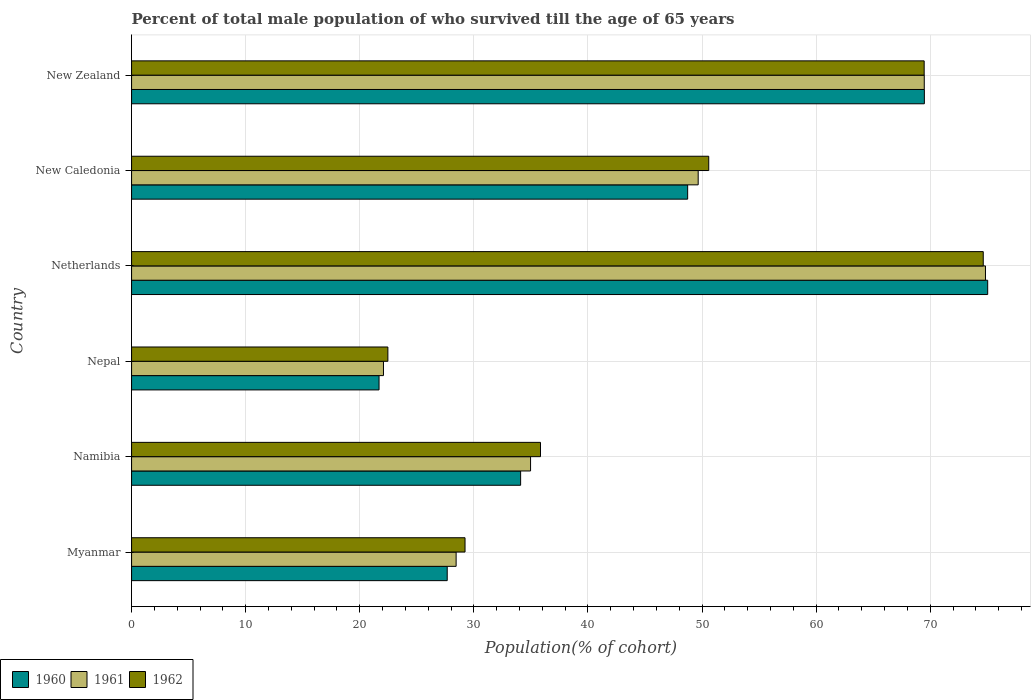Are the number of bars on each tick of the Y-axis equal?
Make the answer very short. Yes. How many bars are there on the 1st tick from the top?
Your answer should be compact. 3. What is the label of the 5th group of bars from the top?
Ensure brevity in your answer.  Namibia. In how many cases, is the number of bars for a given country not equal to the number of legend labels?
Provide a succinct answer. 0. What is the percentage of total male population who survived till the age of 65 years in 1960 in Netherlands?
Your response must be concise. 75.04. Across all countries, what is the maximum percentage of total male population who survived till the age of 65 years in 1962?
Keep it short and to the point. 74.65. Across all countries, what is the minimum percentage of total male population who survived till the age of 65 years in 1961?
Keep it short and to the point. 22.08. In which country was the percentage of total male population who survived till the age of 65 years in 1962 maximum?
Provide a short and direct response. Netherlands. In which country was the percentage of total male population who survived till the age of 65 years in 1962 minimum?
Your response must be concise. Nepal. What is the total percentage of total male population who survived till the age of 65 years in 1960 in the graph?
Your answer should be compact. 276.73. What is the difference between the percentage of total male population who survived till the age of 65 years in 1961 in Netherlands and that in New Zealand?
Offer a terse response. 5.36. What is the difference between the percentage of total male population who survived till the age of 65 years in 1962 in Netherlands and the percentage of total male population who survived till the age of 65 years in 1960 in New Caledonia?
Keep it short and to the point. 25.91. What is the average percentage of total male population who survived till the age of 65 years in 1962 per country?
Offer a very short reply. 47.04. What is the difference between the percentage of total male population who survived till the age of 65 years in 1961 and percentage of total male population who survived till the age of 65 years in 1962 in Netherlands?
Your answer should be compact. 0.19. In how many countries, is the percentage of total male population who survived till the age of 65 years in 1962 greater than 10 %?
Provide a short and direct response. 6. What is the ratio of the percentage of total male population who survived till the age of 65 years in 1962 in Nepal to that in Netherlands?
Your answer should be compact. 0.3. Is the percentage of total male population who survived till the age of 65 years in 1962 in Myanmar less than that in Nepal?
Your answer should be very brief. No. Is the difference between the percentage of total male population who survived till the age of 65 years in 1961 in Nepal and Netherlands greater than the difference between the percentage of total male population who survived till the age of 65 years in 1962 in Nepal and Netherlands?
Your answer should be compact. No. What is the difference between the highest and the second highest percentage of total male population who survived till the age of 65 years in 1961?
Provide a short and direct response. 5.36. What is the difference between the highest and the lowest percentage of total male population who survived till the age of 65 years in 1960?
Provide a short and direct response. 53.35. In how many countries, is the percentage of total male population who survived till the age of 65 years in 1961 greater than the average percentage of total male population who survived till the age of 65 years in 1961 taken over all countries?
Ensure brevity in your answer.  3. What does the 2nd bar from the top in Myanmar represents?
Offer a very short reply. 1961. Is it the case that in every country, the sum of the percentage of total male population who survived till the age of 65 years in 1961 and percentage of total male population who survived till the age of 65 years in 1960 is greater than the percentage of total male population who survived till the age of 65 years in 1962?
Give a very brief answer. Yes. Are all the bars in the graph horizontal?
Offer a very short reply. Yes. Are the values on the major ticks of X-axis written in scientific E-notation?
Provide a short and direct response. No. Does the graph contain grids?
Offer a very short reply. Yes. What is the title of the graph?
Your answer should be very brief. Percent of total male population of who survived till the age of 65 years. What is the label or title of the X-axis?
Provide a short and direct response. Population(% of cohort). What is the Population(% of cohort) of 1960 in Myanmar?
Provide a succinct answer. 27.67. What is the Population(% of cohort) of 1961 in Myanmar?
Your response must be concise. 28.45. What is the Population(% of cohort) of 1962 in Myanmar?
Ensure brevity in your answer.  29.23. What is the Population(% of cohort) in 1960 in Namibia?
Make the answer very short. 34.1. What is the Population(% of cohort) of 1961 in Namibia?
Ensure brevity in your answer.  34.97. What is the Population(% of cohort) of 1962 in Namibia?
Make the answer very short. 35.84. What is the Population(% of cohort) in 1960 in Nepal?
Provide a short and direct response. 21.69. What is the Population(% of cohort) in 1961 in Nepal?
Ensure brevity in your answer.  22.08. What is the Population(% of cohort) in 1962 in Nepal?
Ensure brevity in your answer.  22.46. What is the Population(% of cohort) in 1960 in Netherlands?
Give a very brief answer. 75.04. What is the Population(% of cohort) of 1961 in Netherlands?
Your response must be concise. 74.84. What is the Population(% of cohort) in 1962 in Netherlands?
Provide a succinct answer. 74.65. What is the Population(% of cohort) in 1960 in New Caledonia?
Ensure brevity in your answer.  48.74. What is the Population(% of cohort) in 1961 in New Caledonia?
Your response must be concise. 49.66. What is the Population(% of cohort) in 1962 in New Caledonia?
Your response must be concise. 50.59. What is the Population(% of cohort) of 1960 in New Zealand?
Your answer should be very brief. 69.49. What is the Population(% of cohort) in 1961 in New Zealand?
Provide a succinct answer. 69.48. What is the Population(% of cohort) in 1962 in New Zealand?
Your response must be concise. 69.47. Across all countries, what is the maximum Population(% of cohort) in 1960?
Offer a terse response. 75.04. Across all countries, what is the maximum Population(% of cohort) in 1961?
Ensure brevity in your answer.  74.84. Across all countries, what is the maximum Population(% of cohort) in 1962?
Your answer should be very brief. 74.65. Across all countries, what is the minimum Population(% of cohort) in 1960?
Ensure brevity in your answer.  21.69. Across all countries, what is the minimum Population(% of cohort) of 1961?
Provide a succinct answer. 22.08. Across all countries, what is the minimum Population(% of cohort) of 1962?
Your response must be concise. 22.46. What is the total Population(% of cohort) in 1960 in the graph?
Your response must be concise. 276.73. What is the total Population(% of cohort) in 1961 in the graph?
Ensure brevity in your answer.  279.48. What is the total Population(% of cohort) in 1962 in the graph?
Make the answer very short. 282.24. What is the difference between the Population(% of cohort) of 1960 in Myanmar and that in Namibia?
Provide a succinct answer. -6.43. What is the difference between the Population(% of cohort) in 1961 in Myanmar and that in Namibia?
Offer a very short reply. -6.52. What is the difference between the Population(% of cohort) of 1962 in Myanmar and that in Namibia?
Provide a succinct answer. -6.62. What is the difference between the Population(% of cohort) of 1960 in Myanmar and that in Nepal?
Offer a very short reply. 5.98. What is the difference between the Population(% of cohort) of 1961 in Myanmar and that in Nepal?
Make the answer very short. 6.37. What is the difference between the Population(% of cohort) of 1962 in Myanmar and that in Nepal?
Provide a short and direct response. 6.76. What is the difference between the Population(% of cohort) in 1960 in Myanmar and that in Netherlands?
Your answer should be very brief. -47.37. What is the difference between the Population(% of cohort) of 1961 in Myanmar and that in Netherlands?
Your response must be concise. -46.4. What is the difference between the Population(% of cohort) of 1962 in Myanmar and that in Netherlands?
Offer a very short reply. -45.42. What is the difference between the Population(% of cohort) in 1960 in Myanmar and that in New Caledonia?
Your answer should be compact. -21.07. What is the difference between the Population(% of cohort) of 1961 in Myanmar and that in New Caledonia?
Give a very brief answer. -21.22. What is the difference between the Population(% of cohort) in 1962 in Myanmar and that in New Caledonia?
Make the answer very short. -21.36. What is the difference between the Population(% of cohort) in 1960 in Myanmar and that in New Zealand?
Offer a very short reply. -41.82. What is the difference between the Population(% of cohort) of 1961 in Myanmar and that in New Zealand?
Give a very brief answer. -41.03. What is the difference between the Population(% of cohort) in 1962 in Myanmar and that in New Zealand?
Provide a succinct answer. -40.24. What is the difference between the Population(% of cohort) of 1960 in Namibia and that in Nepal?
Offer a very short reply. 12.41. What is the difference between the Population(% of cohort) in 1961 in Namibia and that in Nepal?
Keep it short and to the point. 12.89. What is the difference between the Population(% of cohort) of 1962 in Namibia and that in Nepal?
Provide a short and direct response. 13.38. What is the difference between the Population(% of cohort) of 1960 in Namibia and that in Netherlands?
Make the answer very short. -40.94. What is the difference between the Population(% of cohort) of 1961 in Namibia and that in Netherlands?
Your answer should be compact. -39.87. What is the difference between the Population(% of cohort) in 1962 in Namibia and that in Netherlands?
Your answer should be compact. -38.81. What is the difference between the Population(% of cohort) of 1960 in Namibia and that in New Caledonia?
Give a very brief answer. -14.64. What is the difference between the Population(% of cohort) of 1961 in Namibia and that in New Caledonia?
Your answer should be very brief. -14.69. What is the difference between the Population(% of cohort) of 1962 in Namibia and that in New Caledonia?
Provide a short and direct response. -14.75. What is the difference between the Population(% of cohort) of 1960 in Namibia and that in New Zealand?
Keep it short and to the point. -35.39. What is the difference between the Population(% of cohort) in 1961 in Namibia and that in New Zealand?
Keep it short and to the point. -34.51. What is the difference between the Population(% of cohort) in 1962 in Namibia and that in New Zealand?
Offer a terse response. -33.63. What is the difference between the Population(% of cohort) of 1960 in Nepal and that in Netherlands?
Your answer should be compact. -53.35. What is the difference between the Population(% of cohort) of 1961 in Nepal and that in Netherlands?
Ensure brevity in your answer.  -52.77. What is the difference between the Population(% of cohort) in 1962 in Nepal and that in Netherlands?
Ensure brevity in your answer.  -52.19. What is the difference between the Population(% of cohort) of 1960 in Nepal and that in New Caledonia?
Your response must be concise. -27.05. What is the difference between the Population(% of cohort) of 1961 in Nepal and that in New Caledonia?
Provide a succinct answer. -27.59. What is the difference between the Population(% of cohort) in 1962 in Nepal and that in New Caledonia?
Your answer should be compact. -28.12. What is the difference between the Population(% of cohort) of 1960 in Nepal and that in New Zealand?
Provide a succinct answer. -47.8. What is the difference between the Population(% of cohort) of 1961 in Nepal and that in New Zealand?
Your response must be concise. -47.4. What is the difference between the Population(% of cohort) in 1962 in Nepal and that in New Zealand?
Your answer should be very brief. -47.01. What is the difference between the Population(% of cohort) in 1960 in Netherlands and that in New Caledonia?
Your answer should be compact. 26.3. What is the difference between the Population(% of cohort) of 1961 in Netherlands and that in New Caledonia?
Provide a short and direct response. 25.18. What is the difference between the Population(% of cohort) in 1962 in Netherlands and that in New Caledonia?
Offer a very short reply. 24.06. What is the difference between the Population(% of cohort) of 1960 in Netherlands and that in New Zealand?
Make the answer very short. 5.55. What is the difference between the Population(% of cohort) in 1961 in Netherlands and that in New Zealand?
Ensure brevity in your answer.  5.36. What is the difference between the Population(% of cohort) of 1962 in Netherlands and that in New Zealand?
Provide a short and direct response. 5.18. What is the difference between the Population(% of cohort) in 1960 in New Caledonia and that in New Zealand?
Offer a terse response. -20.75. What is the difference between the Population(% of cohort) in 1961 in New Caledonia and that in New Zealand?
Provide a short and direct response. -19.82. What is the difference between the Population(% of cohort) of 1962 in New Caledonia and that in New Zealand?
Your response must be concise. -18.88. What is the difference between the Population(% of cohort) of 1960 in Myanmar and the Population(% of cohort) of 1961 in Namibia?
Offer a terse response. -7.3. What is the difference between the Population(% of cohort) of 1960 in Myanmar and the Population(% of cohort) of 1962 in Namibia?
Keep it short and to the point. -8.18. What is the difference between the Population(% of cohort) in 1961 in Myanmar and the Population(% of cohort) in 1962 in Namibia?
Make the answer very short. -7.4. What is the difference between the Population(% of cohort) in 1960 in Myanmar and the Population(% of cohort) in 1961 in Nepal?
Offer a very short reply. 5.59. What is the difference between the Population(% of cohort) of 1960 in Myanmar and the Population(% of cohort) of 1962 in Nepal?
Your response must be concise. 5.2. What is the difference between the Population(% of cohort) of 1961 in Myanmar and the Population(% of cohort) of 1962 in Nepal?
Provide a short and direct response. 5.98. What is the difference between the Population(% of cohort) of 1960 in Myanmar and the Population(% of cohort) of 1961 in Netherlands?
Provide a short and direct response. -47.18. What is the difference between the Population(% of cohort) in 1960 in Myanmar and the Population(% of cohort) in 1962 in Netherlands?
Your response must be concise. -46.98. What is the difference between the Population(% of cohort) of 1961 in Myanmar and the Population(% of cohort) of 1962 in Netherlands?
Offer a very short reply. -46.2. What is the difference between the Population(% of cohort) of 1960 in Myanmar and the Population(% of cohort) of 1961 in New Caledonia?
Make the answer very short. -22. What is the difference between the Population(% of cohort) of 1960 in Myanmar and the Population(% of cohort) of 1962 in New Caledonia?
Your response must be concise. -22.92. What is the difference between the Population(% of cohort) of 1961 in Myanmar and the Population(% of cohort) of 1962 in New Caledonia?
Give a very brief answer. -22.14. What is the difference between the Population(% of cohort) of 1960 in Myanmar and the Population(% of cohort) of 1961 in New Zealand?
Give a very brief answer. -41.81. What is the difference between the Population(% of cohort) of 1960 in Myanmar and the Population(% of cohort) of 1962 in New Zealand?
Your answer should be very brief. -41.8. What is the difference between the Population(% of cohort) of 1961 in Myanmar and the Population(% of cohort) of 1962 in New Zealand?
Offer a terse response. -41.02. What is the difference between the Population(% of cohort) of 1960 in Namibia and the Population(% of cohort) of 1961 in Nepal?
Ensure brevity in your answer.  12.02. What is the difference between the Population(% of cohort) in 1960 in Namibia and the Population(% of cohort) in 1962 in Nepal?
Make the answer very short. 11.64. What is the difference between the Population(% of cohort) in 1961 in Namibia and the Population(% of cohort) in 1962 in Nepal?
Provide a succinct answer. 12.51. What is the difference between the Population(% of cohort) of 1960 in Namibia and the Population(% of cohort) of 1961 in Netherlands?
Keep it short and to the point. -40.74. What is the difference between the Population(% of cohort) of 1960 in Namibia and the Population(% of cohort) of 1962 in Netherlands?
Provide a succinct answer. -40.55. What is the difference between the Population(% of cohort) in 1961 in Namibia and the Population(% of cohort) in 1962 in Netherlands?
Ensure brevity in your answer.  -39.68. What is the difference between the Population(% of cohort) in 1960 in Namibia and the Population(% of cohort) in 1961 in New Caledonia?
Your answer should be compact. -15.56. What is the difference between the Population(% of cohort) in 1960 in Namibia and the Population(% of cohort) in 1962 in New Caledonia?
Offer a terse response. -16.49. What is the difference between the Population(% of cohort) in 1961 in Namibia and the Population(% of cohort) in 1962 in New Caledonia?
Give a very brief answer. -15.62. What is the difference between the Population(% of cohort) in 1960 in Namibia and the Population(% of cohort) in 1961 in New Zealand?
Your response must be concise. -35.38. What is the difference between the Population(% of cohort) of 1960 in Namibia and the Population(% of cohort) of 1962 in New Zealand?
Provide a succinct answer. -35.37. What is the difference between the Population(% of cohort) of 1961 in Namibia and the Population(% of cohort) of 1962 in New Zealand?
Your response must be concise. -34.5. What is the difference between the Population(% of cohort) of 1960 in Nepal and the Population(% of cohort) of 1961 in Netherlands?
Give a very brief answer. -53.15. What is the difference between the Population(% of cohort) in 1960 in Nepal and the Population(% of cohort) in 1962 in Netherlands?
Ensure brevity in your answer.  -52.96. What is the difference between the Population(% of cohort) in 1961 in Nepal and the Population(% of cohort) in 1962 in Netherlands?
Offer a terse response. -52.57. What is the difference between the Population(% of cohort) in 1960 in Nepal and the Population(% of cohort) in 1961 in New Caledonia?
Your response must be concise. -27.97. What is the difference between the Population(% of cohort) of 1960 in Nepal and the Population(% of cohort) of 1962 in New Caledonia?
Offer a very short reply. -28.9. What is the difference between the Population(% of cohort) in 1961 in Nepal and the Population(% of cohort) in 1962 in New Caledonia?
Offer a very short reply. -28.51. What is the difference between the Population(% of cohort) of 1960 in Nepal and the Population(% of cohort) of 1961 in New Zealand?
Ensure brevity in your answer.  -47.79. What is the difference between the Population(% of cohort) in 1960 in Nepal and the Population(% of cohort) in 1962 in New Zealand?
Give a very brief answer. -47.78. What is the difference between the Population(% of cohort) in 1961 in Nepal and the Population(% of cohort) in 1962 in New Zealand?
Provide a short and direct response. -47.39. What is the difference between the Population(% of cohort) of 1960 in Netherlands and the Population(% of cohort) of 1961 in New Caledonia?
Ensure brevity in your answer.  25.37. What is the difference between the Population(% of cohort) in 1960 in Netherlands and the Population(% of cohort) in 1962 in New Caledonia?
Offer a very short reply. 24.45. What is the difference between the Population(% of cohort) of 1961 in Netherlands and the Population(% of cohort) of 1962 in New Caledonia?
Offer a terse response. 24.26. What is the difference between the Population(% of cohort) of 1960 in Netherlands and the Population(% of cohort) of 1961 in New Zealand?
Your answer should be compact. 5.56. What is the difference between the Population(% of cohort) of 1960 in Netherlands and the Population(% of cohort) of 1962 in New Zealand?
Your answer should be compact. 5.57. What is the difference between the Population(% of cohort) in 1961 in Netherlands and the Population(% of cohort) in 1962 in New Zealand?
Ensure brevity in your answer.  5.37. What is the difference between the Population(% of cohort) in 1960 in New Caledonia and the Population(% of cohort) in 1961 in New Zealand?
Keep it short and to the point. -20.74. What is the difference between the Population(% of cohort) of 1960 in New Caledonia and the Population(% of cohort) of 1962 in New Zealand?
Provide a short and direct response. -20.73. What is the difference between the Population(% of cohort) in 1961 in New Caledonia and the Population(% of cohort) in 1962 in New Zealand?
Ensure brevity in your answer.  -19.81. What is the average Population(% of cohort) of 1960 per country?
Ensure brevity in your answer.  46.12. What is the average Population(% of cohort) of 1961 per country?
Give a very brief answer. 46.58. What is the average Population(% of cohort) of 1962 per country?
Provide a short and direct response. 47.04. What is the difference between the Population(% of cohort) of 1960 and Population(% of cohort) of 1961 in Myanmar?
Give a very brief answer. -0.78. What is the difference between the Population(% of cohort) in 1960 and Population(% of cohort) in 1962 in Myanmar?
Offer a terse response. -1.56. What is the difference between the Population(% of cohort) of 1961 and Population(% of cohort) of 1962 in Myanmar?
Provide a short and direct response. -0.78. What is the difference between the Population(% of cohort) of 1960 and Population(% of cohort) of 1961 in Namibia?
Offer a terse response. -0.87. What is the difference between the Population(% of cohort) in 1960 and Population(% of cohort) in 1962 in Namibia?
Keep it short and to the point. -1.74. What is the difference between the Population(% of cohort) in 1961 and Population(% of cohort) in 1962 in Namibia?
Ensure brevity in your answer.  -0.87. What is the difference between the Population(% of cohort) in 1960 and Population(% of cohort) in 1961 in Nepal?
Keep it short and to the point. -0.39. What is the difference between the Population(% of cohort) of 1960 and Population(% of cohort) of 1962 in Nepal?
Provide a succinct answer. -0.77. What is the difference between the Population(% of cohort) of 1961 and Population(% of cohort) of 1962 in Nepal?
Keep it short and to the point. -0.39. What is the difference between the Population(% of cohort) of 1960 and Population(% of cohort) of 1961 in Netherlands?
Ensure brevity in your answer.  0.19. What is the difference between the Population(% of cohort) of 1960 and Population(% of cohort) of 1962 in Netherlands?
Your answer should be very brief. 0.39. What is the difference between the Population(% of cohort) in 1961 and Population(% of cohort) in 1962 in Netherlands?
Your answer should be very brief. 0.19. What is the difference between the Population(% of cohort) of 1960 and Population(% of cohort) of 1961 in New Caledonia?
Your answer should be compact. -0.92. What is the difference between the Population(% of cohort) in 1960 and Population(% of cohort) in 1962 in New Caledonia?
Offer a terse response. -1.85. What is the difference between the Population(% of cohort) of 1961 and Population(% of cohort) of 1962 in New Caledonia?
Make the answer very short. -0.92. What is the difference between the Population(% of cohort) of 1960 and Population(% of cohort) of 1961 in New Zealand?
Ensure brevity in your answer.  0.01. What is the difference between the Population(% of cohort) of 1960 and Population(% of cohort) of 1962 in New Zealand?
Make the answer very short. 0.02. What is the difference between the Population(% of cohort) of 1961 and Population(% of cohort) of 1962 in New Zealand?
Keep it short and to the point. 0.01. What is the ratio of the Population(% of cohort) in 1960 in Myanmar to that in Namibia?
Give a very brief answer. 0.81. What is the ratio of the Population(% of cohort) in 1961 in Myanmar to that in Namibia?
Keep it short and to the point. 0.81. What is the ratio of the Population(% of cohort) in 1962 in Myanmar to that in Namibia?
Make the answer very short. 0.82. What is the ratio of the Population(% of cohort) in 1960 in Myanmar to that in Nepal?
Your answer should be compact. 1.28. What is the ratio of the Population(% of cohort) in 1961 in Myanmar to that in Nepal?
Offer a terse response. 1.29. What is the ratio of the Population(% of cohort) in 1962 in Myanmar to that in Nepal?
Offer a terse response. 1.3. What is the ratio of the Population(% of cohort) of 1960 in Myanmar to that in Netherlands?
Your answer should be very brief. 0.37. What is the ratio of the Population(% of cohort) of 1961 in Myanmar to that in Netherlands?
Ensure brevity in your answer.  0.38. What is the ratio of the Population(% of cohort) of 1962 in Myanmar to that in Netherlands?
Keep it short and to the point. 0.39. What is the ratio of the Population(% of cohort) in 1960 in Myanmar to that in New Caledonia?
Your answer should be very brief. 0.57. What is the ratio of the Population(% of cohort) of 1961 in Myanmar to that in New Caledonia?
Provide a short and direct response. 0.57. What is the ratio of the Population(% of cohort) of 1962 in Myanmar to that in New Caledonia?
Make the answer very short. 0.58. What is the ratio of the Population(% of cohort) of 1960 in Myanmar to that in New Zealand?
Your response must be concise. 0.4. What is the ratio of the Population(% of cohort) of 1961 in Myanmar to that in New Zealand?
Provide a succinct answer. 0.41. What is the ratio of the Population(% of cohort) in 1962 in Myanmar to that in New Zealand?
Provide a succinct answer. 0.42. What is the ratio of the Population(% of cohort) in 1960 in Namibia to that in Nepal?
Offer a terse response. 1.57. What is the ratio of the Population(% of cohort) in 1961 in Namibia to that in Nepal?
Your response must be concise. 1.58. What is the ratio of the Population(% of cohort) of 1962 in Namibia to that in Nepal?
Your answer should be very brief. 1.6. What is the ratio of the Population(% of cohort) in 1960 in Namibia to that in Netherlands?
Your answer should be compact. 0.45. What is the ratio of the Population(% of cohort) in 1961 in Namibia to that in Netherlands?
Provide a succinct answer. 0.47. What is the ratio of the Population(% of cohort) in 1962 in Namibia to that in Netherlands?
Ensure brevity in your answer.  0.48. What is the ratio of the Population(% of cohort) in 1960 in Namibia to that in New Caledonia?
Offer a terse response. 0.7. What is the ratio of the Population(% of cohort) in 1961 in Namibia to that in New Caledonia?
Ensure brevity in your answer.  0.7. What is the ratio of the Population(% of cohort) in 1962 in Namibia to that in New Caledonia?
Give a very brief answer. 0.71. What is the ratio of the Population(% of cohort) of 1960 in Namibia to that in New Zealand?
Your answer should be compact. 0.49. What is the ratio of the Population(% of cohort) in 1961 in Namibia to that in New Zealand?
Keep it short and to the point. 0.5. What is the ratio of the Population(% of cohort) in 1962 in Namibia to that in New Zealand?
Give a very brief answer. 0.52. What is the ratio of the Population(% of cohort) of 1960 in Nepal to that in Netherlands?
Your answer should be compact. 0.29. What is the ratio of the Population(% of cohort) in 1961 in Nepal to that in Netherlands?
Ensure brevity in your answer.  0.29. What is the ratio of the Population(% of cohort) in 1962 in Nepal to that in Netherlands?
Offer a very short reply. 0.3. What is the ratio of the Population(% of cohort) of 1960 in Nepal to that in New Caledonia?
Offer a very short reply. 0.45. What is the ratio of the Population(% of cohort) of 1961 in Nepal to that in New Caledonia?
Ensure brevity in your answer.  0.44. What is the ratio of the Population(% of cohort) of 1962 in Nepal to that in New Caledonia?
Provide a short and direct response. 0.44. What is the ratio of the Population(% of cohort) in 1960 in Nepal to that in New Zealand?
Give a very brief answer. 0.31. What is the ratio of the Population(% of cohort) in 1961 in Nepal to that in New Zealand?
Ensure brevity in your answer.  0.32. What is the ratio of the Population(% of cohort) in 1962 in Nepal to that in New Zealand?
Ensure brevity in your answer.  0.32. What is the ratio of the Population(% of cohort) in 1960 in Netherlands to that in New Caledonia?
Your answer should be compact. 1.54. What is the ratio of the Population(% of cohort) in 1961 in Netherlands to that in New Caledonia?
Provide a short and direct response. 1.51. What is the ratio of the Population(% of cohort) in 1962 in Netherlands to that in New Caledonia?
Offer a very short reply. 1.48. What is the ratio of the Population(% of cohort) in 1960 in Netherlands to that in New Zealand?
Ensure brevity in your answer.  1.08. What is the ratio of the Population(% of cohort) in 1961 in Netherlands to that in New Zealand?
Keep it short and to the point. 1.08. What is the ratio of the Population(% of cohort) of 1962 in Netherlands to that in New Zealand?
Ensure brevity in your answer.  1.07. What is the ratio of the Population(% of cohort) in 1960 in New Caledonia to that in New Zealand?
Provide a succinct answer. 0.7. What is the ratio of the Population(% of cohort) in 1961 in New Caledonia to that in New Zealand?
Offer a very short reply. 0.71. What is the ratio of the Population(% of cohort) of 1962 in New Caledonia to that in New Zealand?
Give a very brief answer. 0.73. What is the difference between the highest and the second highest Population(% of cohort) of 1960?
Your answer should be compact. 5.55. What is the difference between the highest and the second highest Population(% of cohort) of 1961?
Offer a very short reply. 5.36. What is the difference between the highest and the second highest Population(% of cohort) in 1962?
Ensure brevity in your answer.  5.18. What is the difference between the highest and the lowest Population(% of cohort) in 1960?
Provide a short and direct response. 53.35. What is the difference between the highest and the lowest Population(% of cohort) of 1961?
Provide a short and direct response. 52.77. What is the difference between the highest and the lowest Population(% of cohort) of 1962?
Ensure brevity in your answer.  52.19. 